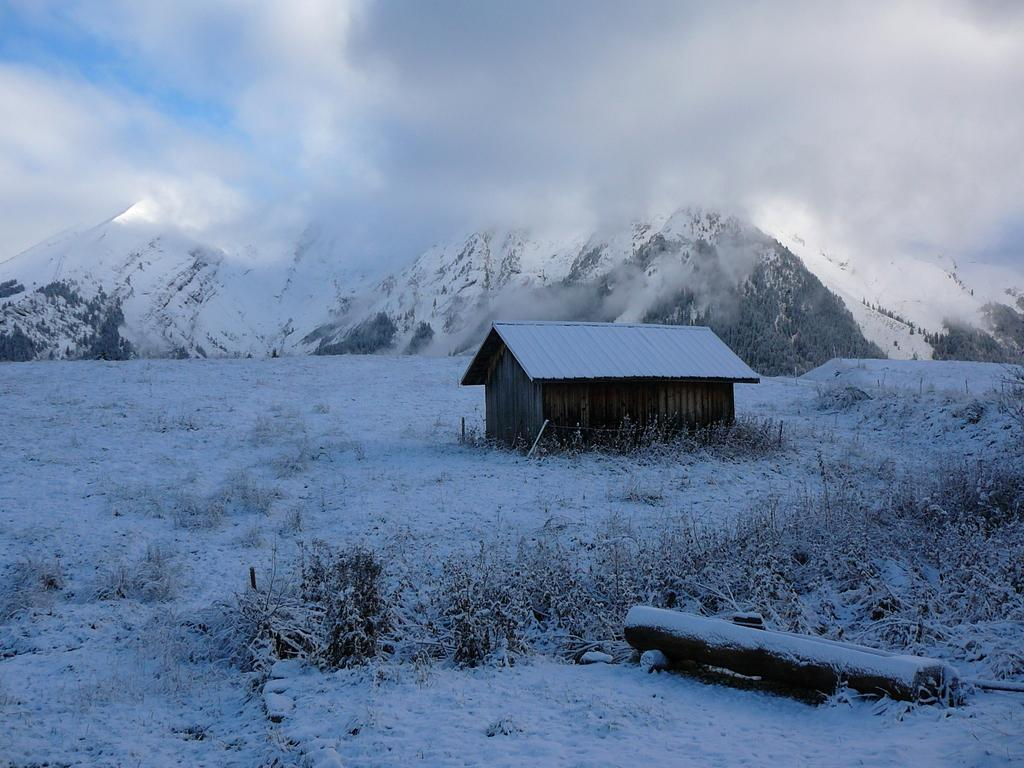What type of structure is present in the image? There is a house in the image. What is the color and condition of the ground in the image? The ground is covered in snow, which is white in color. What can be seen in the distance behind the house? There are mountains visible in the background. How would you describe the sky in the image? The sky is a combination of white and blue colors. Can you see any soap bubbles floating around the house in the image? There are no soap bubbles present in the image. Is there a wave crashing against the house in the image? There is no wave present in the image; it features a house with a snowy background and mountains in the distance. 